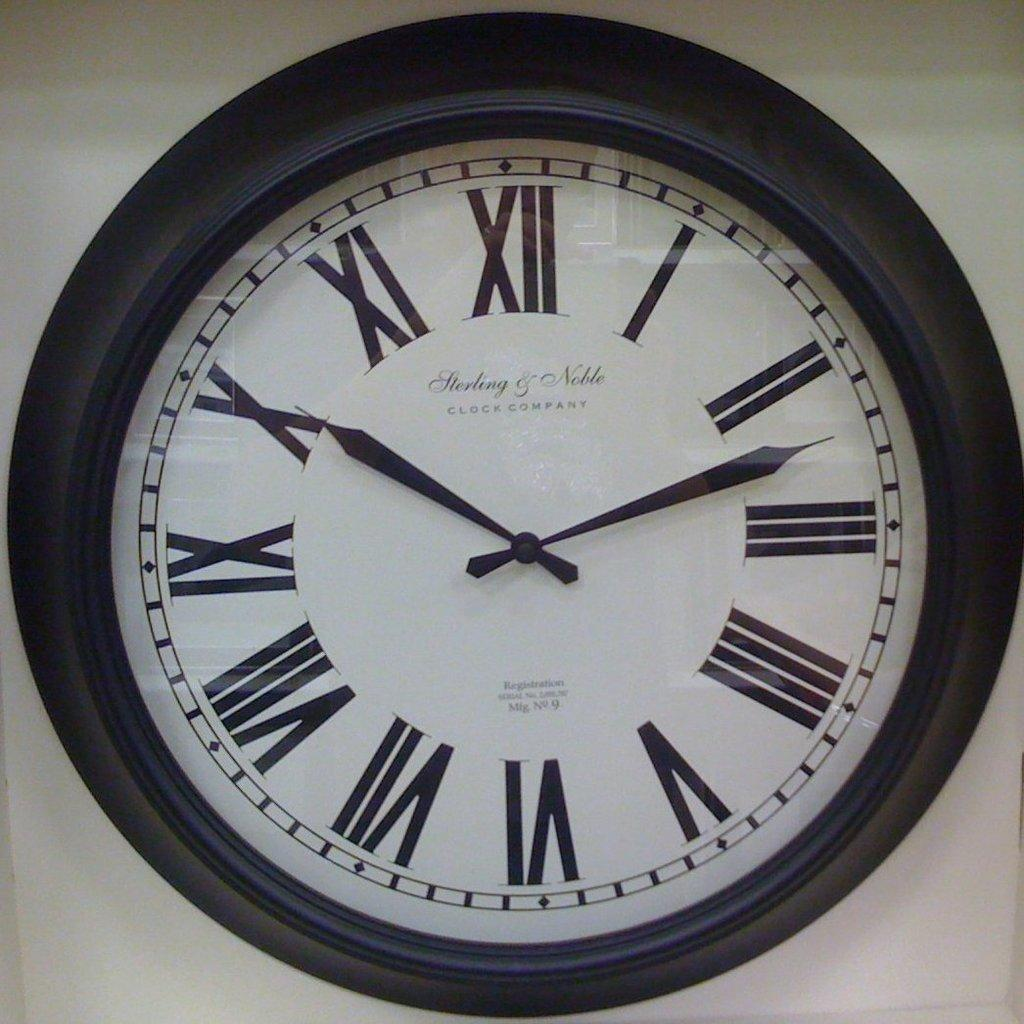<image>
Write a terse but informative summary of the picture. A Sterling & Noble Clock Company clock reads the time of 1:51. 